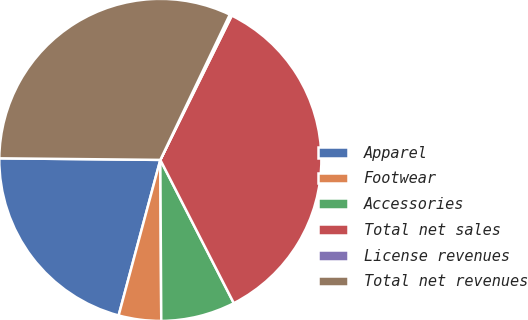<chart> <loc_0><loc_0><loc_500><loc_500><pie_chart><fcel>Apparel<fcel>Footwear<fcel>Accessories<fcel>Total net sales<fcel>License revenues<fcel>Total net revenues<nl><fcel>20.99%<fcel>4.26%<fcel>7.45%<fcel>35.14%<fcel>0.22%<fcel>31.94%<nl></chart> 